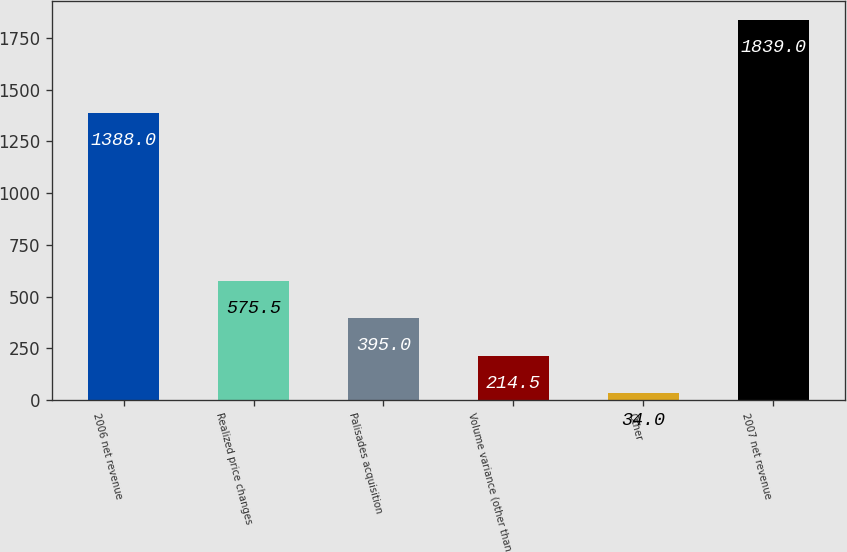<chart> <loc_0><loc_0><loc_500><loc_500><bar_chart><fcel>2006 net revenue<fcel>Realized price changes<fcel>Palisades acquisition<fcel>Volume variance (other than<fcel>Other<fcel>2007 net revenue<nl><fcel>1388<fcel>575.5<fcel>395<fcel>214.5<fcel>34<fcel>1839<nl></chart> 